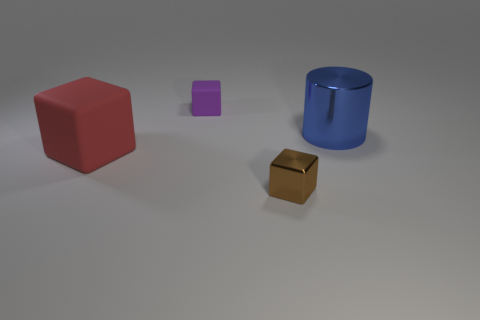What number of other things are the same size as the metal block?
Offer a very short reply. 1. Do the purple matte thing and the blue thing have the same size?
Give a very brief answer. No. Is the size of the cylinder the same as the matte thing in front of the large blue cylinder?
Keep it short and to the point. Yes. There is a matte thing that is behind the thing that is right of the tiny brown metal object; what color is it?
Your answer should be compact. Purple. How many other things are there of the same color as the big cylinder?
Give a very brief answer. 0. What size is the blue metal cylinder?
Ensure brevity in your answer.  Large. Are there more brown blocks on the left side of the large red thing than large rubber objects in front of the brown metal block?
Give a very brief answer. No. There is a tiny thing that is to the right of the tiny purple matte block; how many small shiny blocks are in front of it?
Make the answer very short. 0. Do the rubber object behind the big cube and the large blue metal thing have the same shape?
Your response must be concise. No. What is the material of the red thing that is the same shape as the tiny purple thing?
Make the answer very short. Rubber. 